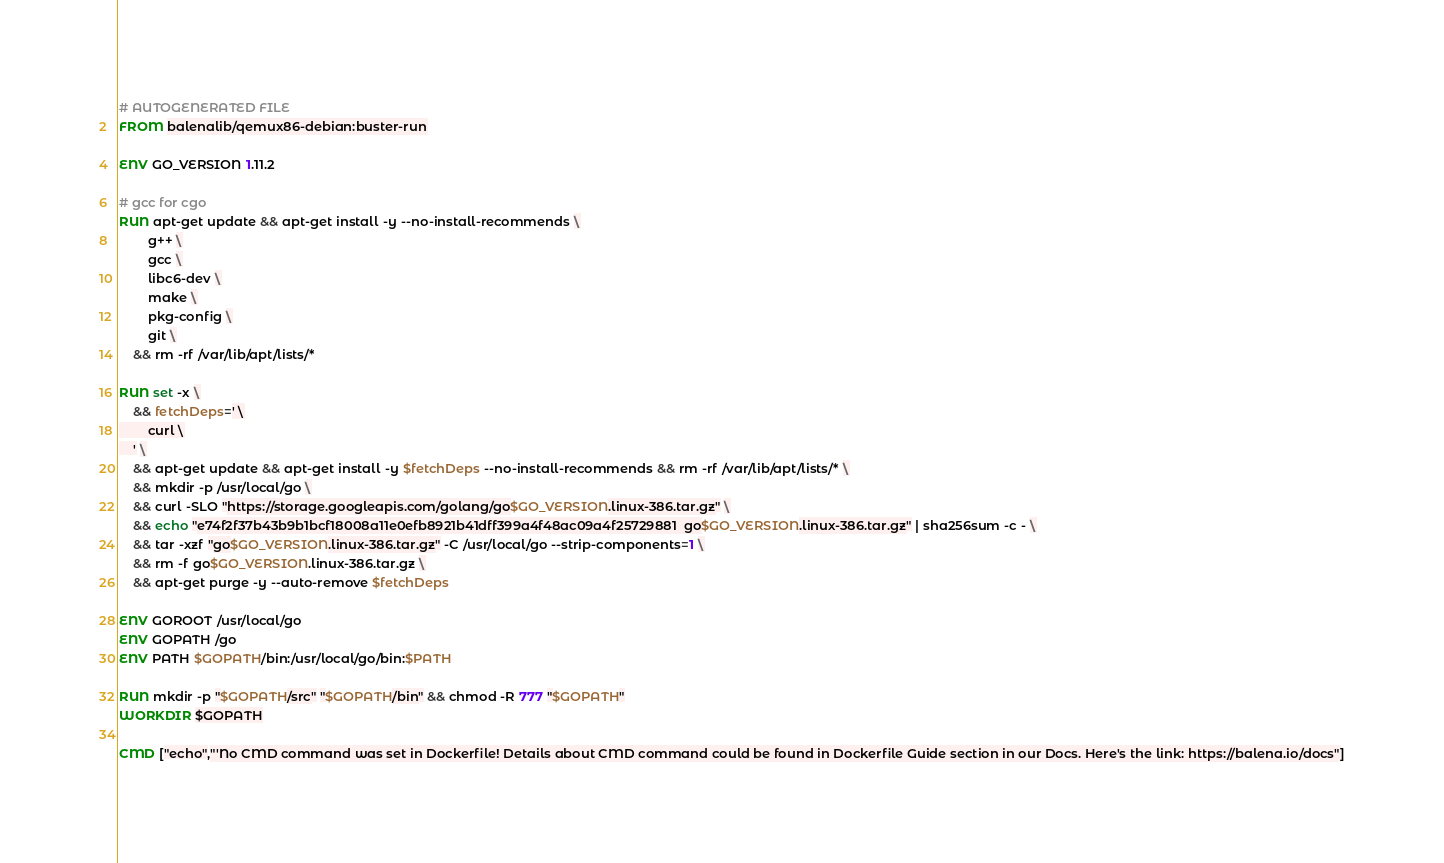<code> <loc_0><loc_0><loc_500><loc_500><_Dockerfile_># AUTOGENERATED FILE
FROM balenalib/qemux86-debian:buster-run

ENV GO_VERSION 1.11.2

# gcc for cgo
RUN apt-get update && apt-get install -y --no-install-recommends \
		g++ \
		gcc \
		libc6-dev \
		make \
		pkg-config \
		git \
	&& rm -rf /var/lib/apt/lists/*

RUN set -x \
	&& fetchDeps=' \
		curl \
	' \
	&& apt-get update && apt-get install -y $fetchDeps --no-install-recommends && rm -rf /var/lib/apt/lists/* \
	&& mkdir -p /usr/local/go \
	&& curl -SLO "https://storage.googleapis.com/golang/go$GO_VERSION.linux-386.tar.gz" \
	&& echo "e74f2f37b43b9b1bcf18008a11e0efb8921b41dff399a4f48ac09a4f25729881  go$GO_VERSION.linux-386.tar.gz" | sha256sum -c - \
	&& tar -xzf "go$GO_VERSION.linux-386.tar.gz" -C /usr/local/go --strip-components=1 \
	&& rm -f go$GO_VERSION.linux-386.tar.gz \
	&& apt-get purge -y --auto-remove $fetchDeps

ENV GOROOT /usr/local/go
ENV GOPATH /go
ENV PATH $GOPATH/bin:/usr/local/go/bin:$PATH

RUN mkdir -p "$GOPATH/src" "$GOPATH/bin" && chmod -R 777 "$GOPATH"
WORKDIR $GOPATH

CMD ["echo","'No CMD command was set in Dockerfile! Details about CMD command could be found in Dockerfile Guide section in our Docs. Here's the link: https://balena.io/docs"]</code> 